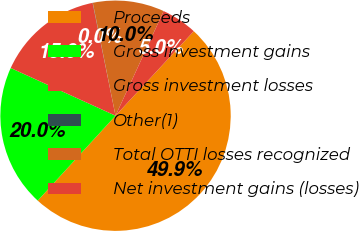Convert chart to OTSL. <chart><loc_0><loc_0><loc_500><loc_500><pie_chart><fcel>Proceeds<fcel>Gross investment gains<fcel>Gross investment losses<fcel>Other(1)<fcel>Total OTTI losses recognized<fcel>Net investment gains (losses)<nl><fcel>49.91%<fcel>19.99%<fcel>15.0%<fcel>0.04%<fcel>10.02%<fcel>5.03%<nl></chart> 